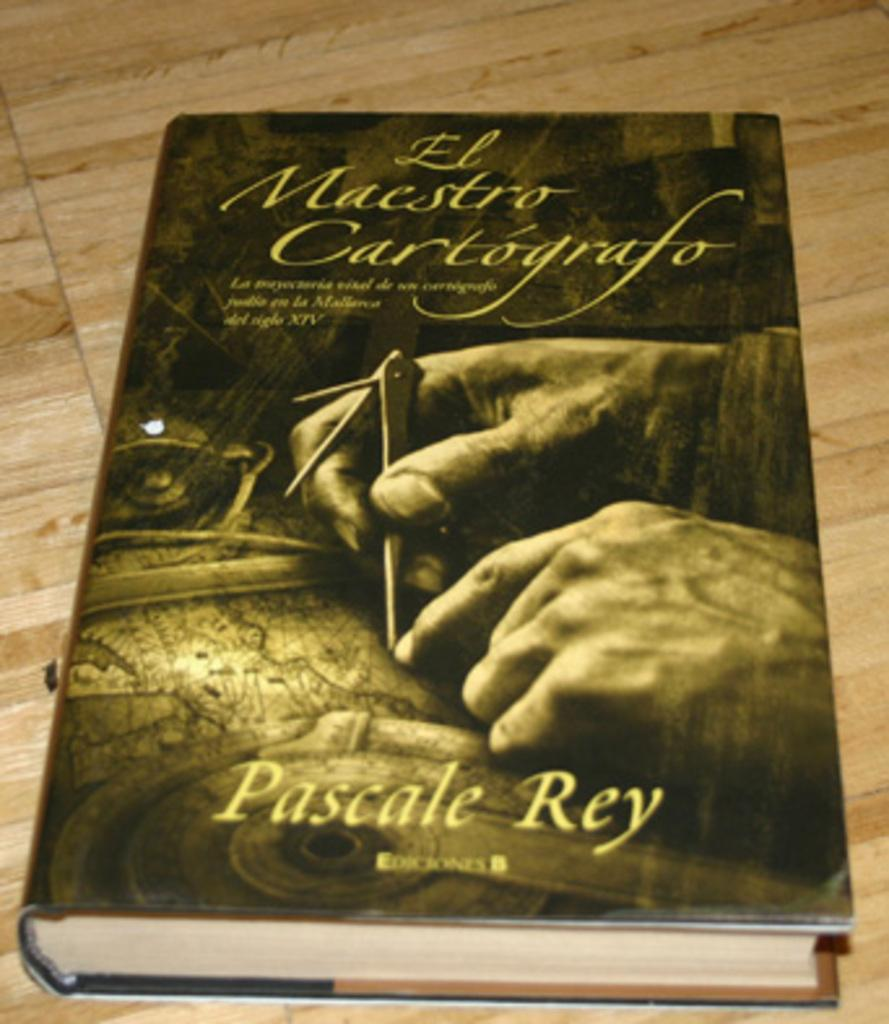<image>
Describe the image concisely. A yellow book is entitled "El Maestro Cartografo". 